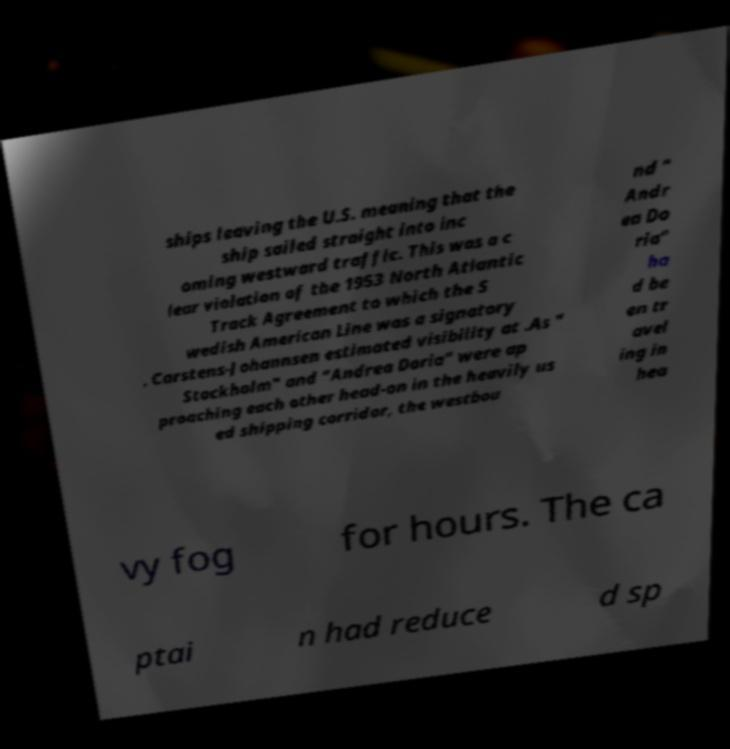There's text embedded in this image that I need extracted. Can you transcribe it verbatim? ships leaving the U.S. meaning that the ship sailed straight into inc oming westward traffic. This was a c lear violation of the 1953 North Atlantic Track Agreement to which the S wedish American Line was a signatory . Carstens-Johannsen estimated visibility at .As " Stockholm" and "Andrea Doria" were ap proaching each other head-on in the heavily us ed shipping corridor, the westbou nd " Andr ea Do ria" ha d be en tr avel ing in hea vy fog for hours. The ca ptai n had reduce d sp 